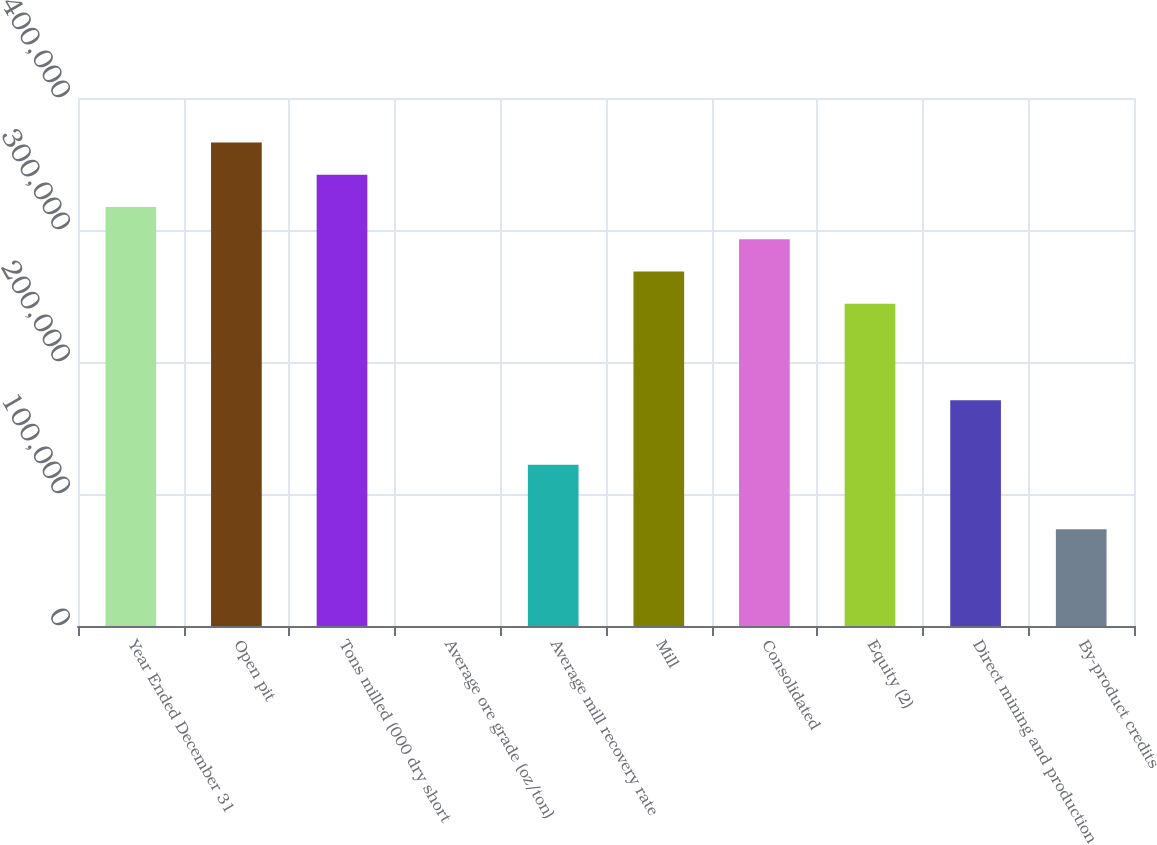Convert chart. <chart><loc_0><loc_0><loc_500><loc_500><bar_chart><fcel>Year Ended December 31<fcel>Open pit<fcel>Tons milled (000 dry short<fcel>Average ore grade (oz/ton)<fcel>Average mill recovery rate<fcel>Mill<fcel>Consolidated<fcel>Equity (2)<fcel>Direct mining and production<fcel>By-product credits<nl><fcel>317486<fcel>366330<fcel>341908<fcel>0.03<fcel>122110<fcel>268642<fcel>293064<fcel>244220<fcel>170954<fcel>73266<nl></chart> 